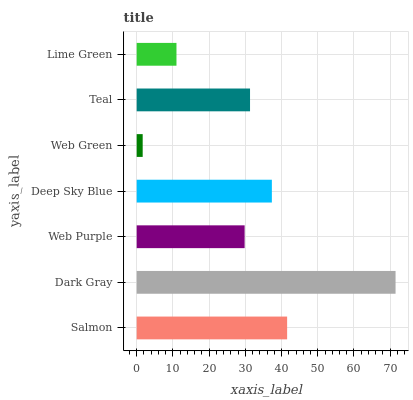Is Web Green the minimum?
Answer yes or no. Yes. Is Dark Gray the maximum?
Answer yes or no. Yes. Is Web Purple the minimum?
Answer yes or no. No. Is Web Purple the maximum?
Answer yes or no. No. Is Dark Gray greater than Web Purple?
Answer yes or no. Yes. Is Web Purple less than Dark Gray?
Answer yes or no. Yes. Is Web Purple greater than Dark Gray?
Answer yes or no. No. Is Dark Gray less than Web Purple?
Answer yes or no. No. Is Teal the high median?
Answer yes or no. Yes. Is Teal the low median?
Answer yes or no. Yes. Is Web Purple the high median?
Answer yes or no. No. Is Deep Sky Blue the low median?
Answer yes or no. No. 